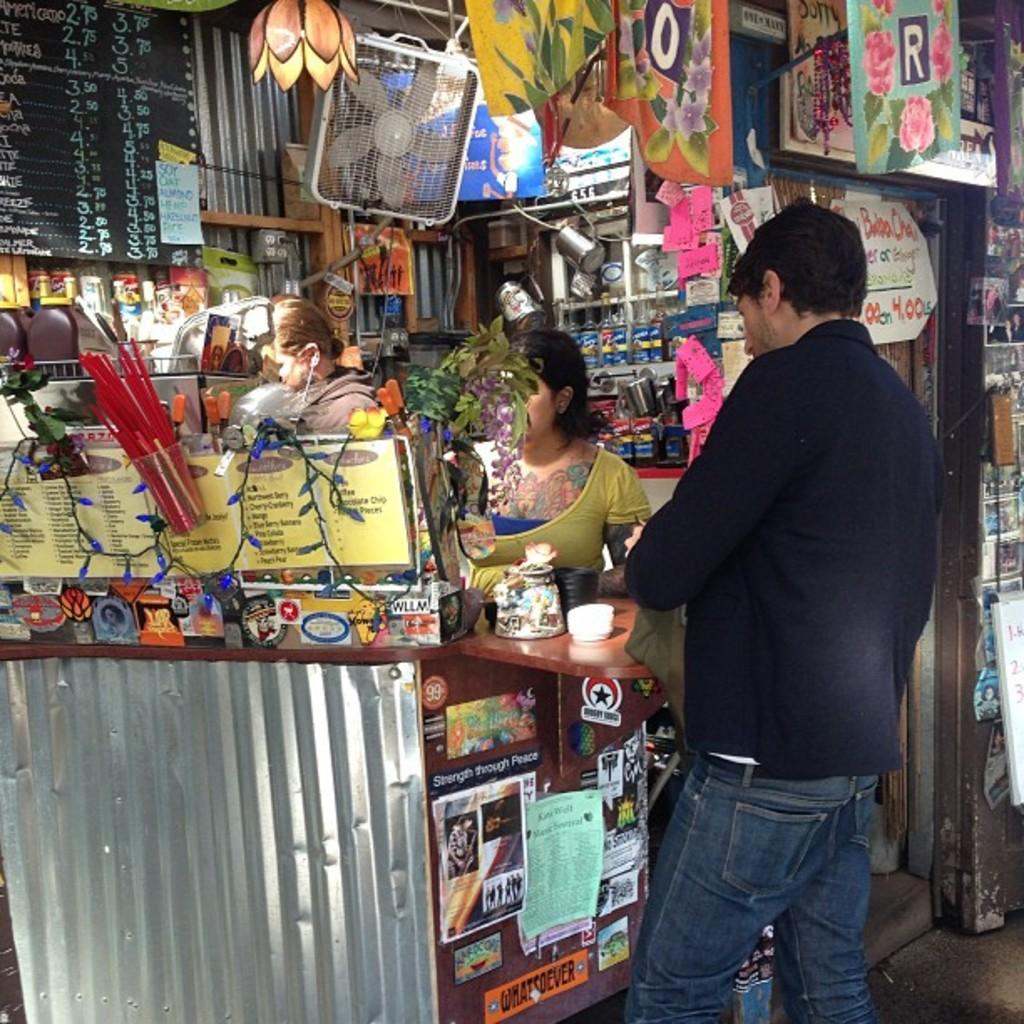<image>
Describe the image concisely. An orange WHATSOEVER sticker sits at the bottom of a counter in a store 